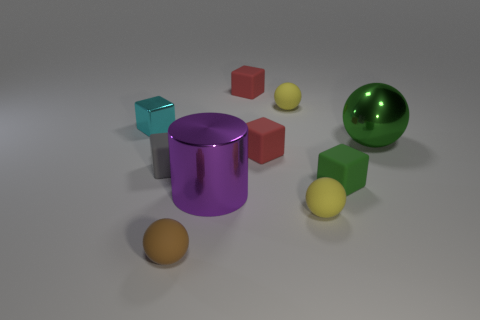Subtract 1 cubes. How many cubes are left? 4 Subtract all green matte blocks. How many blocks are left? 4 Subtract all green cubes. How many cubes are left? 4 Subtract all blue cubes. Subtract all green cylinders. How many cubes are left? 5 Subtract all cylinders. How many objects are left? 9 Add 8 big gray cylinders. How many big gray cylinders exist? 8 Subtract 0 brown cylinders. How many objects are left? 10 Subtract all yellow spheres. Subtract all big purple shiny cylinders. How many objects are left? 7 Add 3 rubber spheres. How many rubber spheres are left? 6 